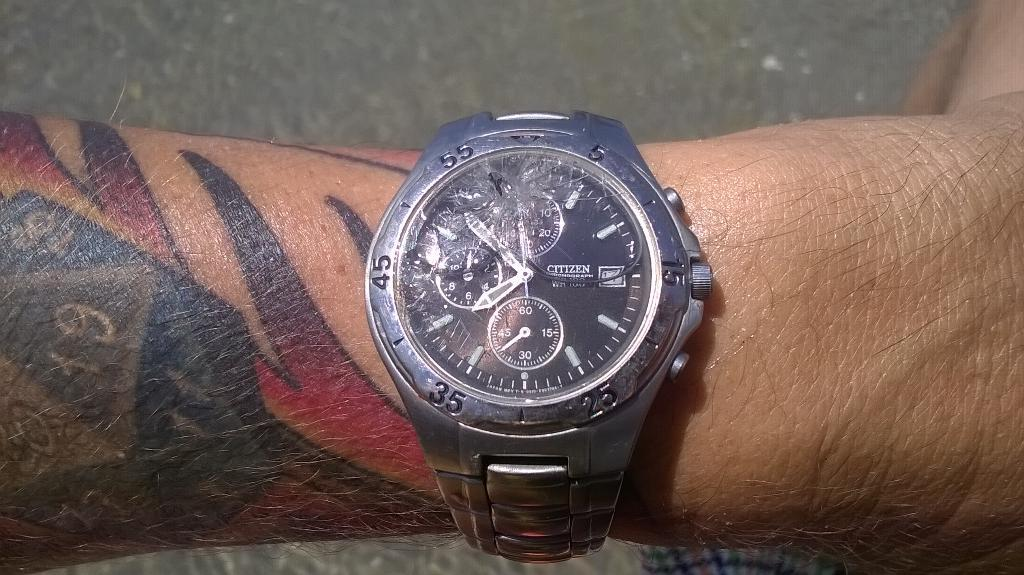<image>
Summarize the visual content of the image. A person with tattoos is wearing a broken silver wristwatch that says Citizen. 